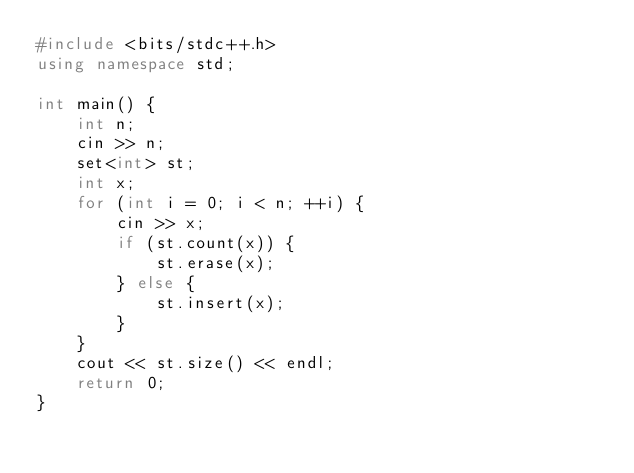<code> <loc_0><loc_0><loc_500><loc_500><_C++_>#include <bits/stdc++.h>
using namespace std;

int main() {
    int n;
    cin >> n;
    set<int> st;
    int x;
    for (int i = 0; i < n; ++i) {
        cin >> x;
        if (st.count(x)) {
            st.erase(x);
        } else {
            st.insert(x);
        }
    }
    cout << st.size() << endl;
    return 0;
}</code> 